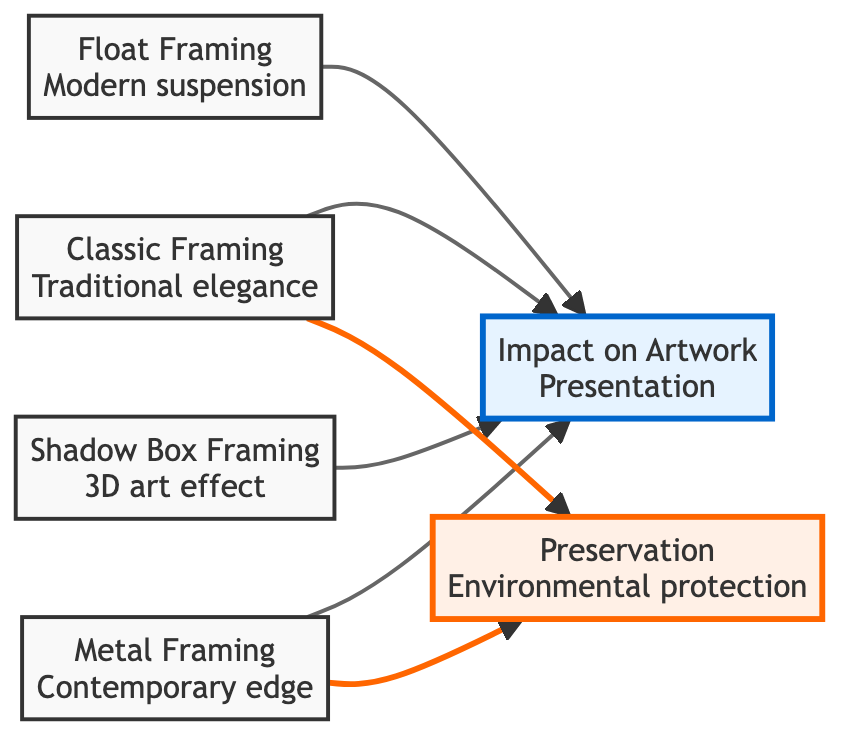What are the types of framing styles shown in the diagram? The diagram lists four types of framing styles: Classic Framing, Float Framing, Shadow Box Framing, and Metal Framing. Each is represented as a node in the diagram.
Answer: Classic Framing, Float Framing, Shadow Box Framing, Metal Framing How many edges are there in the diagram? Each line or connection between the nodes represents an edge. Counting the connections from Classic Framing, Float Framing, Shadow Box Framing, and Metal Framing to the Art Impact node gives four edges. Additionally, Classic Framing and Metal Framing each connect to the Preservation node, adding two more edges, for a total of six edges.
Answer: 6 Which framing styles have an impact on artwork presentation? This question asks to identify all the nodes that connect to the Art Impact node. Both Classic Framing, Float Framing, Shadow Box Framing, and Metal Framing point to Art Impact, indicating these styles all impact artwork presentation.
Answer: Classic Framing, Float Framing, Shadow Box Framing, Metal Framing Which framing styles provide better preservation? The Preservation node is only linked to Classic Framing and Metal Framing based on the connections in the diagram. Thus, these are the only two framing styles that are noted for providing better protection against environmental damage.
Answer: Classic Framing, Metal Framing Is there a direct connection from Float Framing to Preservation? To determine if there's a direct connection from Float Framing to Preservation, we check the edges emanating from Float Framing. There is no arrow pointing from Float Framing to the Preservation node, which indicates there is no direct link.
Answer: No 